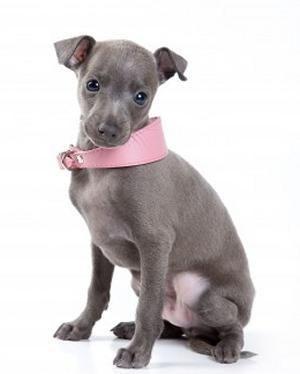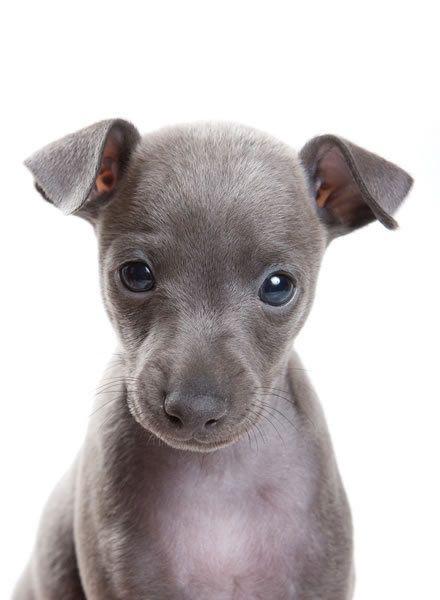The first image is the image on the left, the second image is the image on the right. For the images shown, is this caption "One of the dogs has a pink collar." true? Answer yes or no. Yes. 